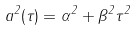<formula> <loc_0><loc_0><loc_500><loc_500>a ^ { 2 } ( \tau ) = \alpha ^ { 2 } + \beta ^ { 2 } \tau ^ { 2 }</formula> 